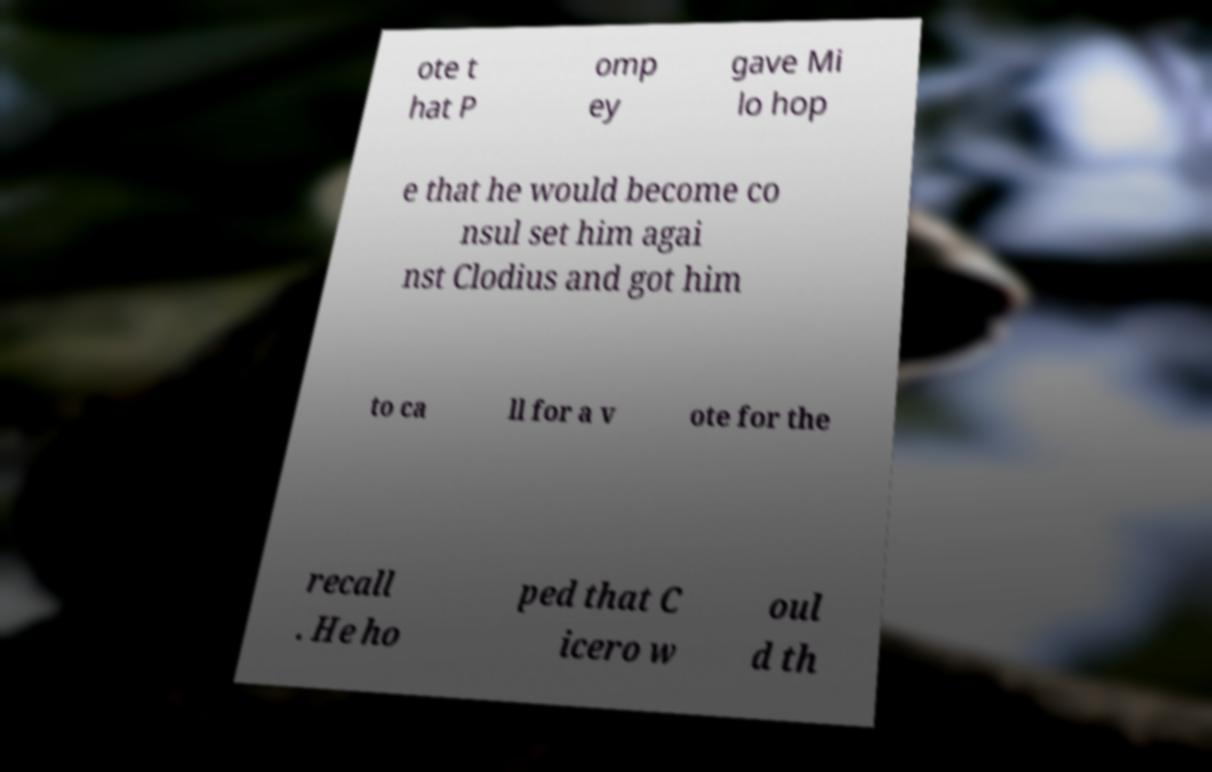Please read and relay the text visible in this image. What does it say? ote t hat P omp ey gave Mi lo hop e that he would become co nsul set him agai nst Clodius and got him to ca ll for a v ote for the recall . He ho ped that C icero w oul d th 